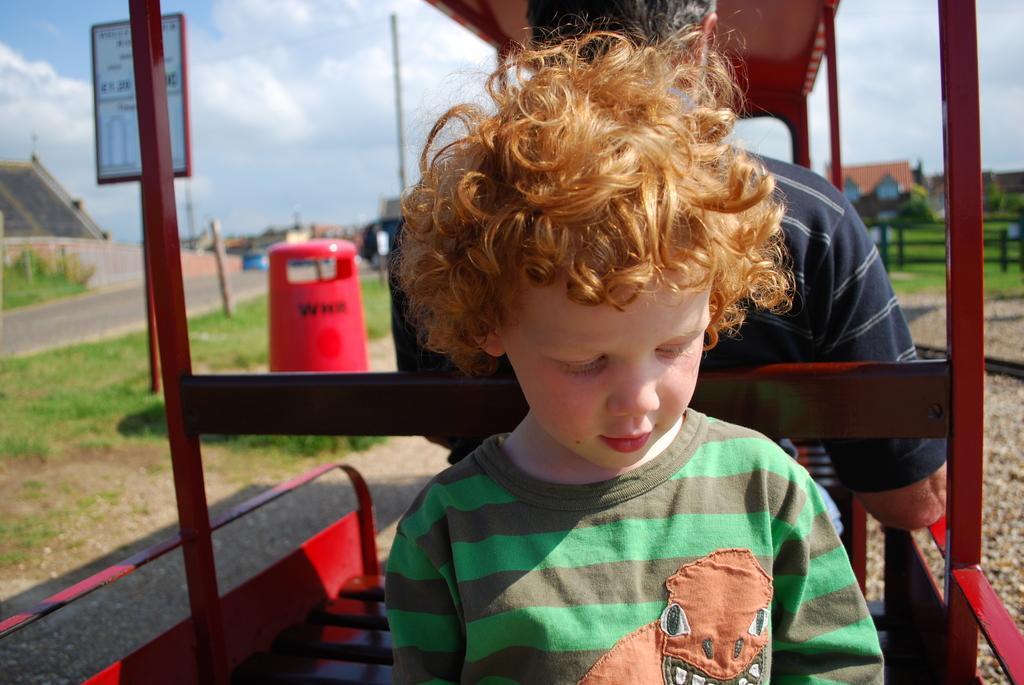How would you summarize this image in a sentence or two? In this image in the foreground there is a vehicle, and in the vehicle there is one boy and one person sitting. And in the background there are some poles, boards, houses, trees, grass, fence. And at the bottom there is grass and road, and at the top there is sky. 